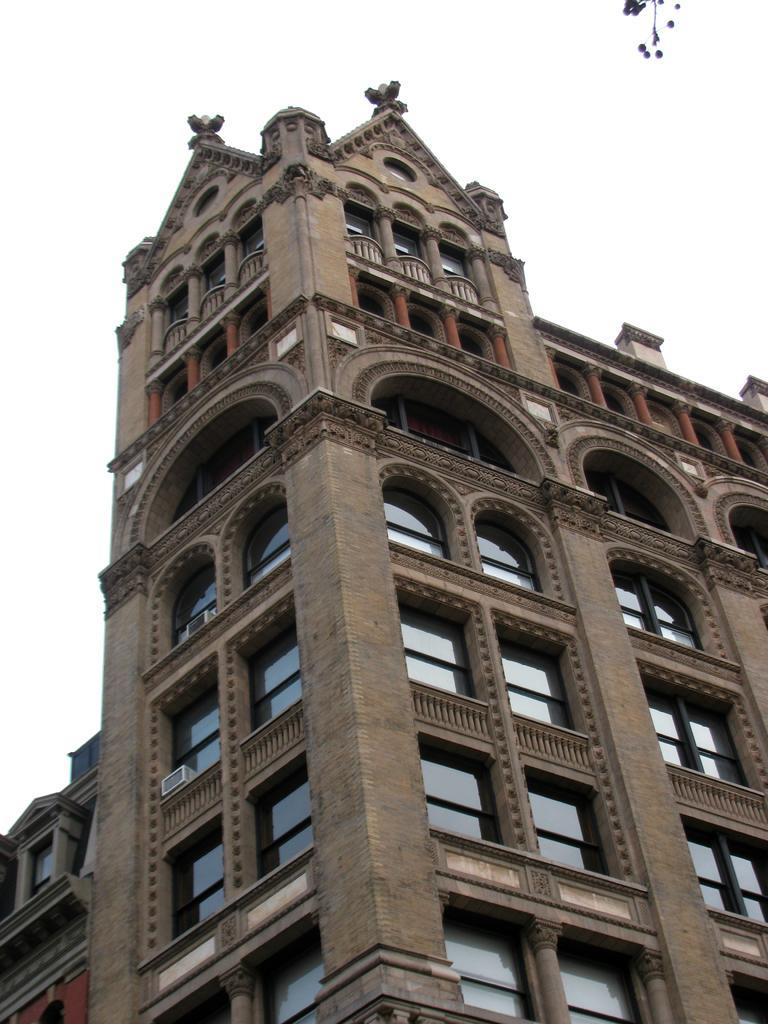How would you summarize this image in a sentence or two? In this image I can see the building and glass windows. The sky is in white color. 